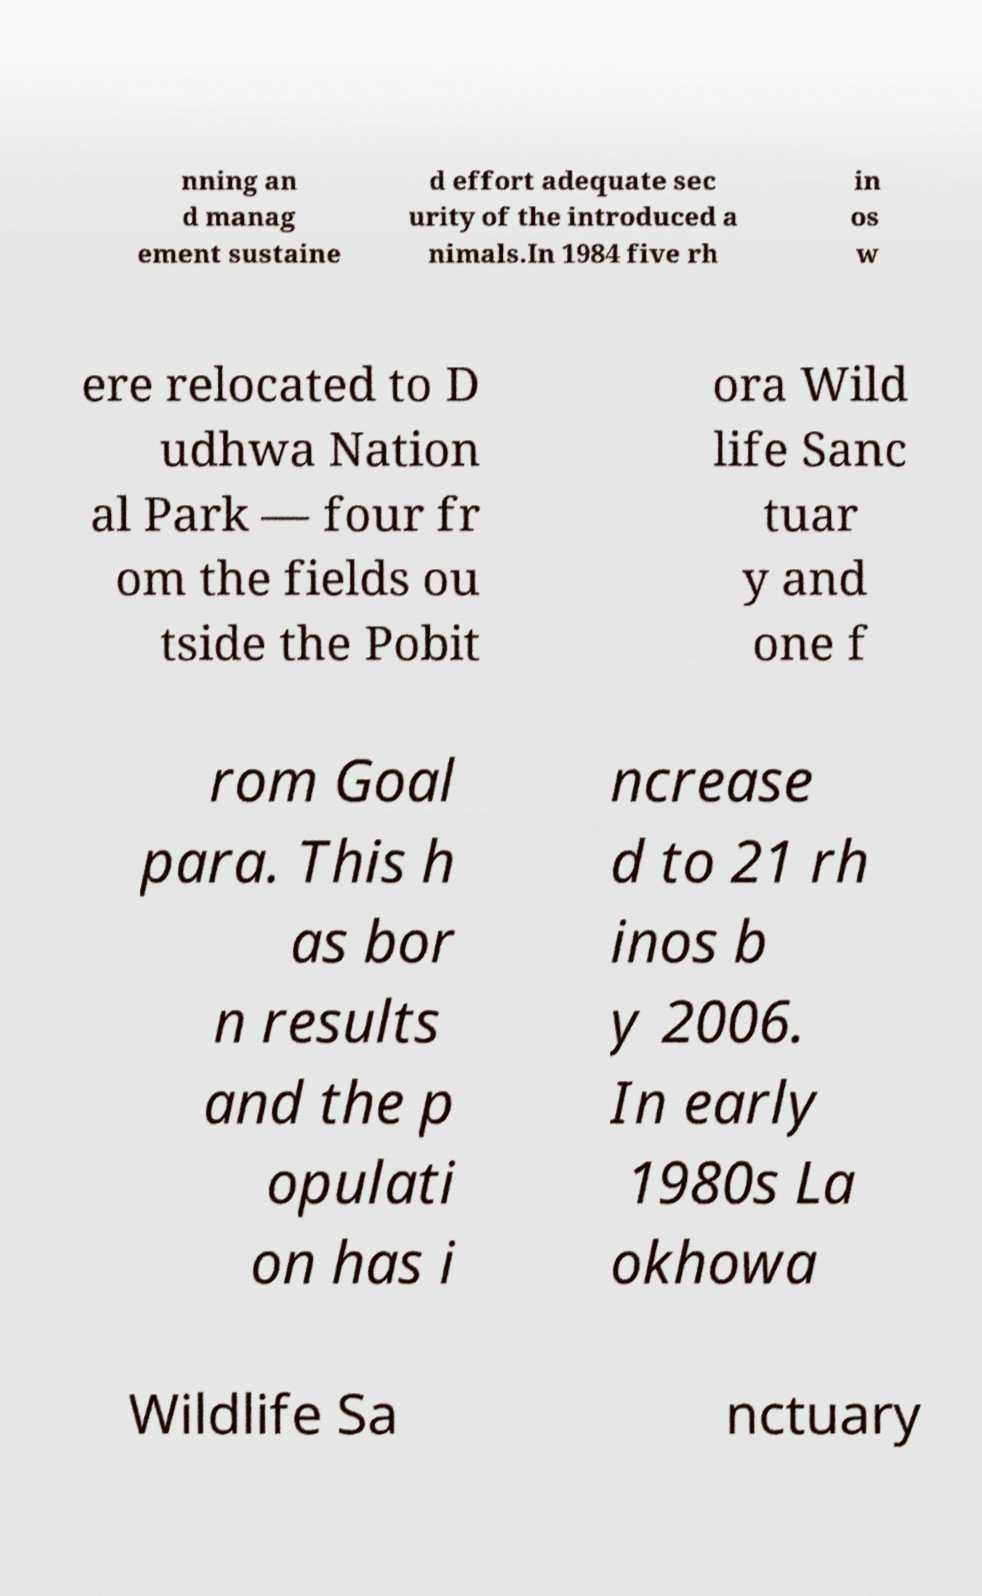Could you assist in decoding the text presented in this image and type it out clearly? nning an d manag ement sustaine d effort adequate sec urity of the introduced a nimals.In 1984 five rh in os w ere relocated to D udhwa Nation al Park — four fr om the fields ou tside the Pobit ora Wild life Sanc tuar y and one f rom Goal para. This h as bor n results and the p opulati on has i ncrease d to 21 rh inos b y 2006. In early 1980s La okhowa Wildlife Sa nctuary 